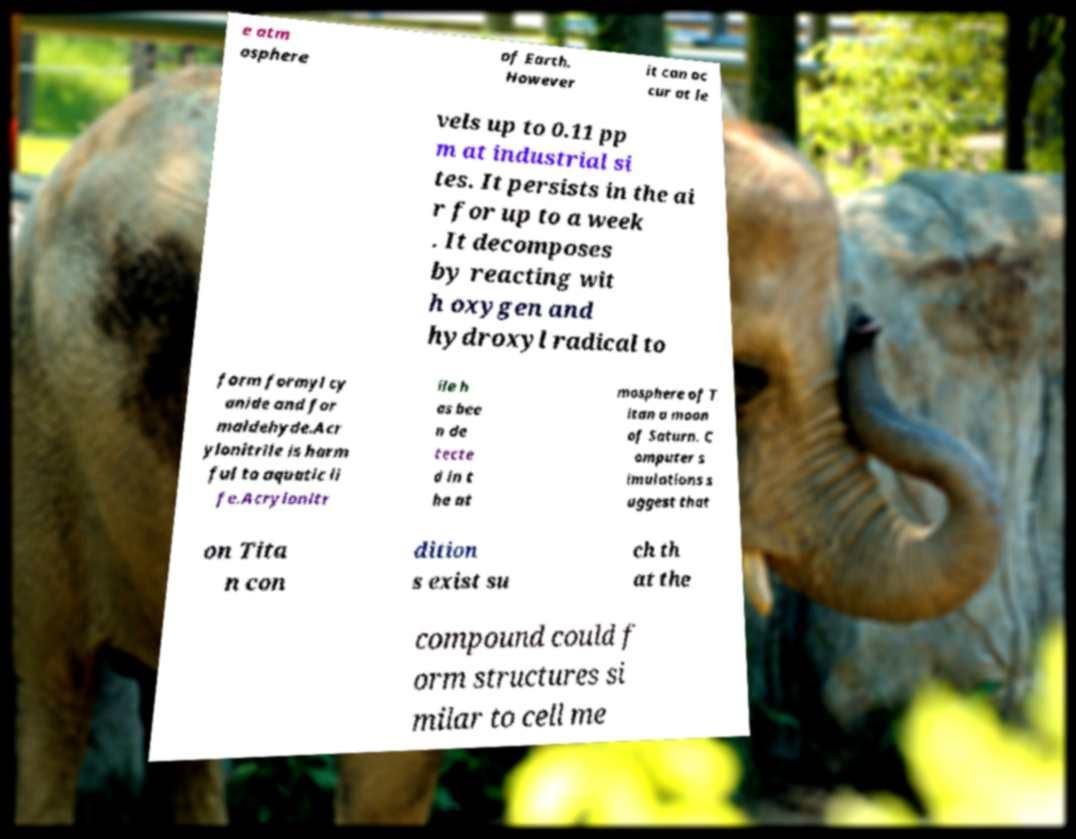Please read and relay the text visible in this image. What does it say? e atm osphere of Earth. However it can oc cur at le vels up to 0.11 pp m at industrial si tes. It persists in the ai r for up to a week . It decomposes by reacting wit h oxygen and hydroxyl radical to form formyl cy anide and for maldehyde.Acr ylonitrile is harm ful to aquatic li fe.Acrylonitr ile h as bee n de tecte d in t he at mosphere of T itan a moon of Saturn. C omputer s imulations s uggest that on Tita n con dition s exist su ch th at the compound could f orm structures si milar to cell me 